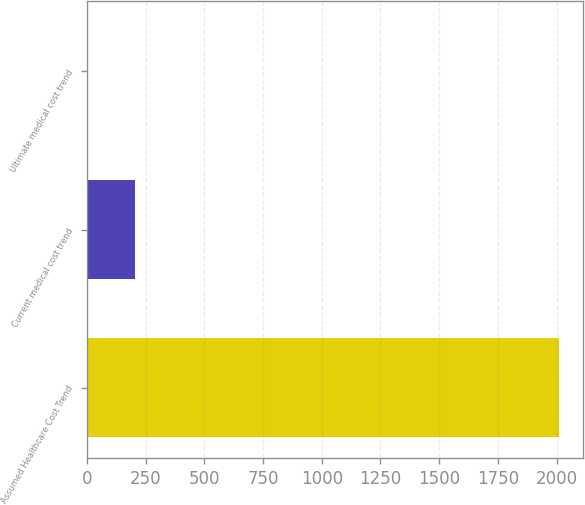<chart> <loc_0><loc_0><loc_500><loc_500><bar_chart><fcel>Assumed Healthcare Cost Trend<fcel>Current medical cost trend<fcel>Ultimate medical cost trend<nl><fcel>2011<fcel>205.15<fcel>4.5<nl></chart> 